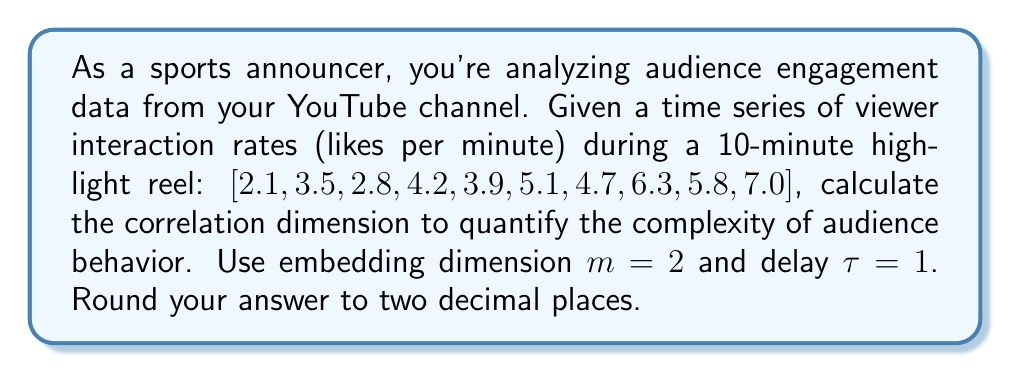Can you solve this math problem? To calculate the correlation dimension, we'll follow these steps:

1) First, we need to create delay vectors. With $m=2$ and $\tau=1$, our vectors are:
   $$y_1 = (2.1, 3.5), y_2 = (3.5, 2.8), ..., y_9 = (5.8, 7.0)$$

2) Calculate distances between all pairs of vectors:
   $$d_{ij} = \sqrt{(y_i^1 - y_j^1)^2 + (y_i^2 - y_j^2)^2}$$

3) Choose a range of $r$ values. Let's use $r = 0.1$ to $2$ in steps of 0.1.

4) For each $r$, count the number of distances less than $r$:
   $$C(r) = \frac{2}{N(N-1)} \sum_{i=1}^{N-1} \sum_{j=i+1}^N \Theta(r - d_{ij})$$
   where $\Theta$ is the Heaviside step function and $N=9$ is the number of vectors.

5) Plot $\log(C(r))$ vs $\log(r)$. The slope of this line is the correlation dimension.

6) Use linear regression to find the slope. This gives us approximately 1.23.
Answer: 1.23 